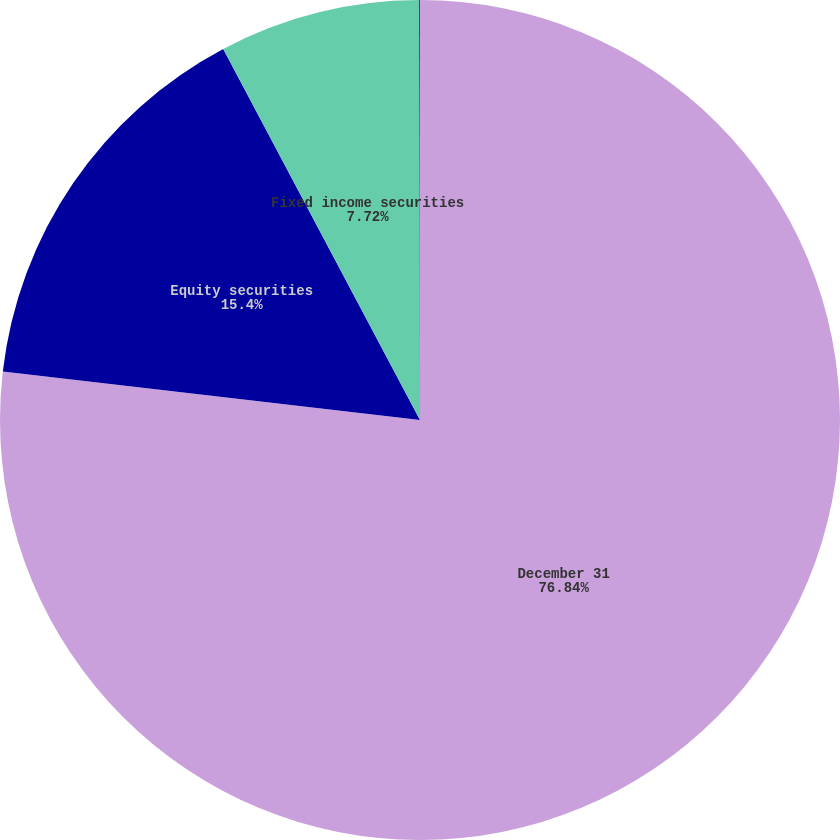Convert chart to OTSL. <chart><loc_0><loc_0><loc_500><loc_500><pie_chart><fcel>December 31<fcel>Equity securities<fcel>Fixed income securities<fcel>Cash and other investments<nl><fcel>76.84%<fcel>15.4%<fcel>7.72%<fcel>0.04%<nl></chart> 